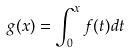Convert formula to latex. <formula><loc_0><loc_0><loc_500><loc_500>g ( x ) = \int _ { 0 } ^ { x } f ( t ) d t</formula> 